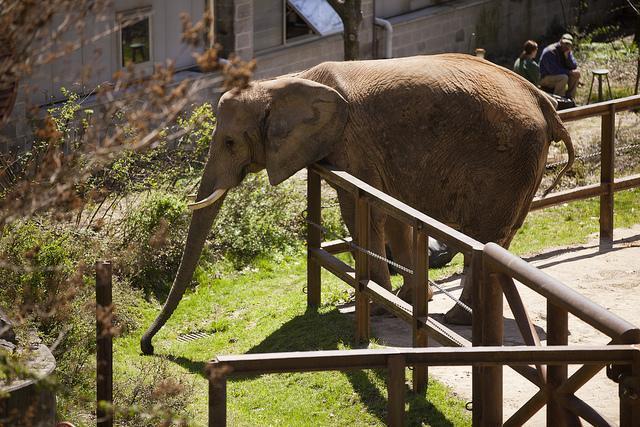How many animals are there?
Give a very brief answer. 1. How many green cars in the picture?
Give a very brief answer. 0. 